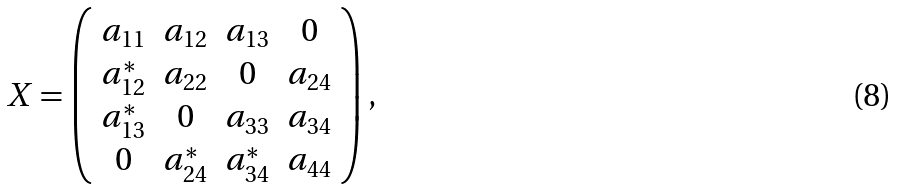<formula> <loc_0><loc_0><loc_500><loc_500>X = \left ( \begin{array} { c c c c } a _ { 1 1 } & a _ { 1 2 } & a _ { 1 3 } & 0 \\ a _ { 1 2 } ^ { * } & a _ { 2 2 } & 0 & a _ { 2 4 } \\ a _ { 1 3 } ^ { * } & 0 & a _ { 3 3 } & a _ { 3 4 } \\ 0 & a _ { 2 4 } ^ { * } & a _ { 3 4 } ^ { * } & a _ { 4 4 } \\ \end{array} \right ) ,</formula> 